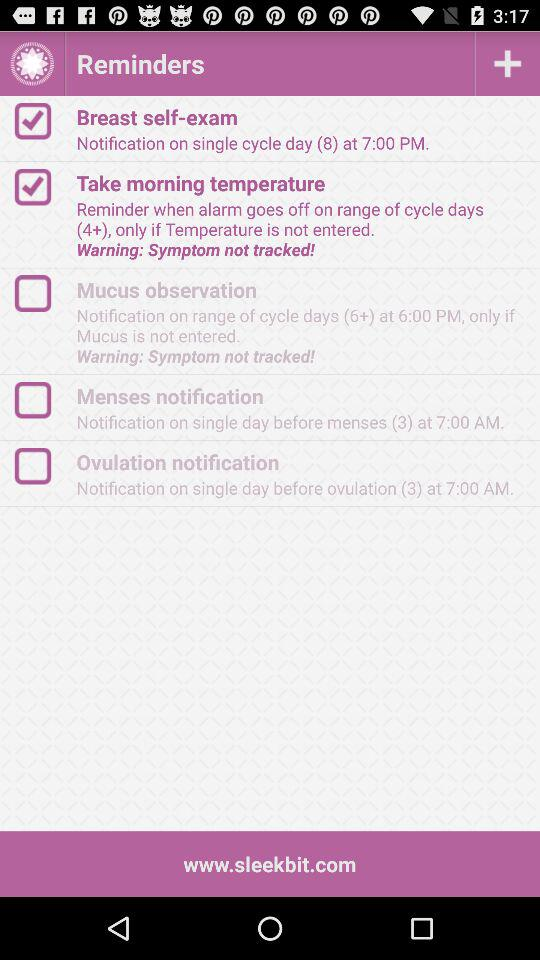What is the website? The website is www.sleekbit.com. 